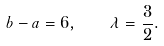<formula> <loc_0><loc_0><loc_500><loc_500>b - a = 6 , \quad \lambda = \frac { 3 } { 2 } .</formula> 